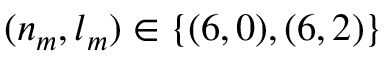Convert formula to latex. <formula><loc_0><loc_0><loc_500><loc_500>( n _ { m } , l _ { m } ) \in \{ ( 6 , 0 ) , ( 6 , 2 ) \}</formula> 